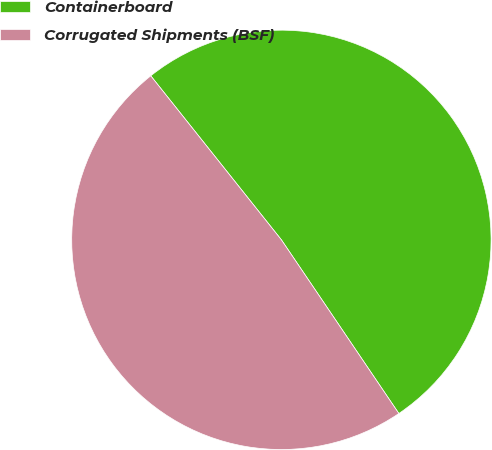Convert chart. <chart><loc_0><loc_0><loc_500><loc_500><pie_chart><fcel>Containerboard<fcel>Corrugated Shipments (BSF)<nl><fcel>51.24%<fcel>48.76%<nl></chart> 